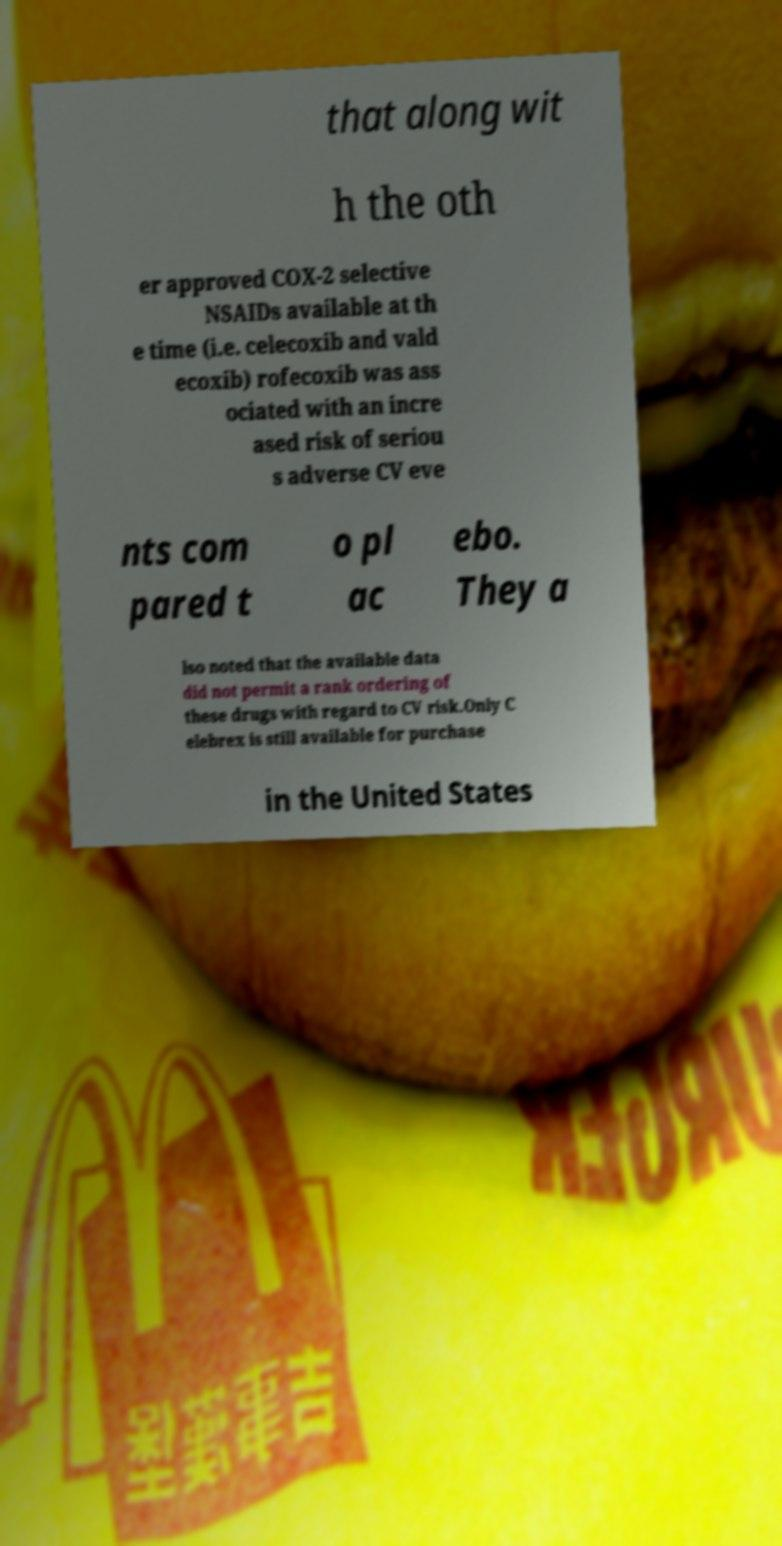Could you extract and type out the text from this image? that along wit h the oth er approved COX-2 selective NSAIDs available at th e time (i.e. celecoxib and vald ecoxib) rofecoxib was ass ociated with an incre ased risk of seriou s adverse CV eve nts com pared t o pl ac ebo. They a lso noted that the available data did not permit a rank ordering of these drugs with regard to CV risk.Only C elebrex is still available for purchase in the United States 